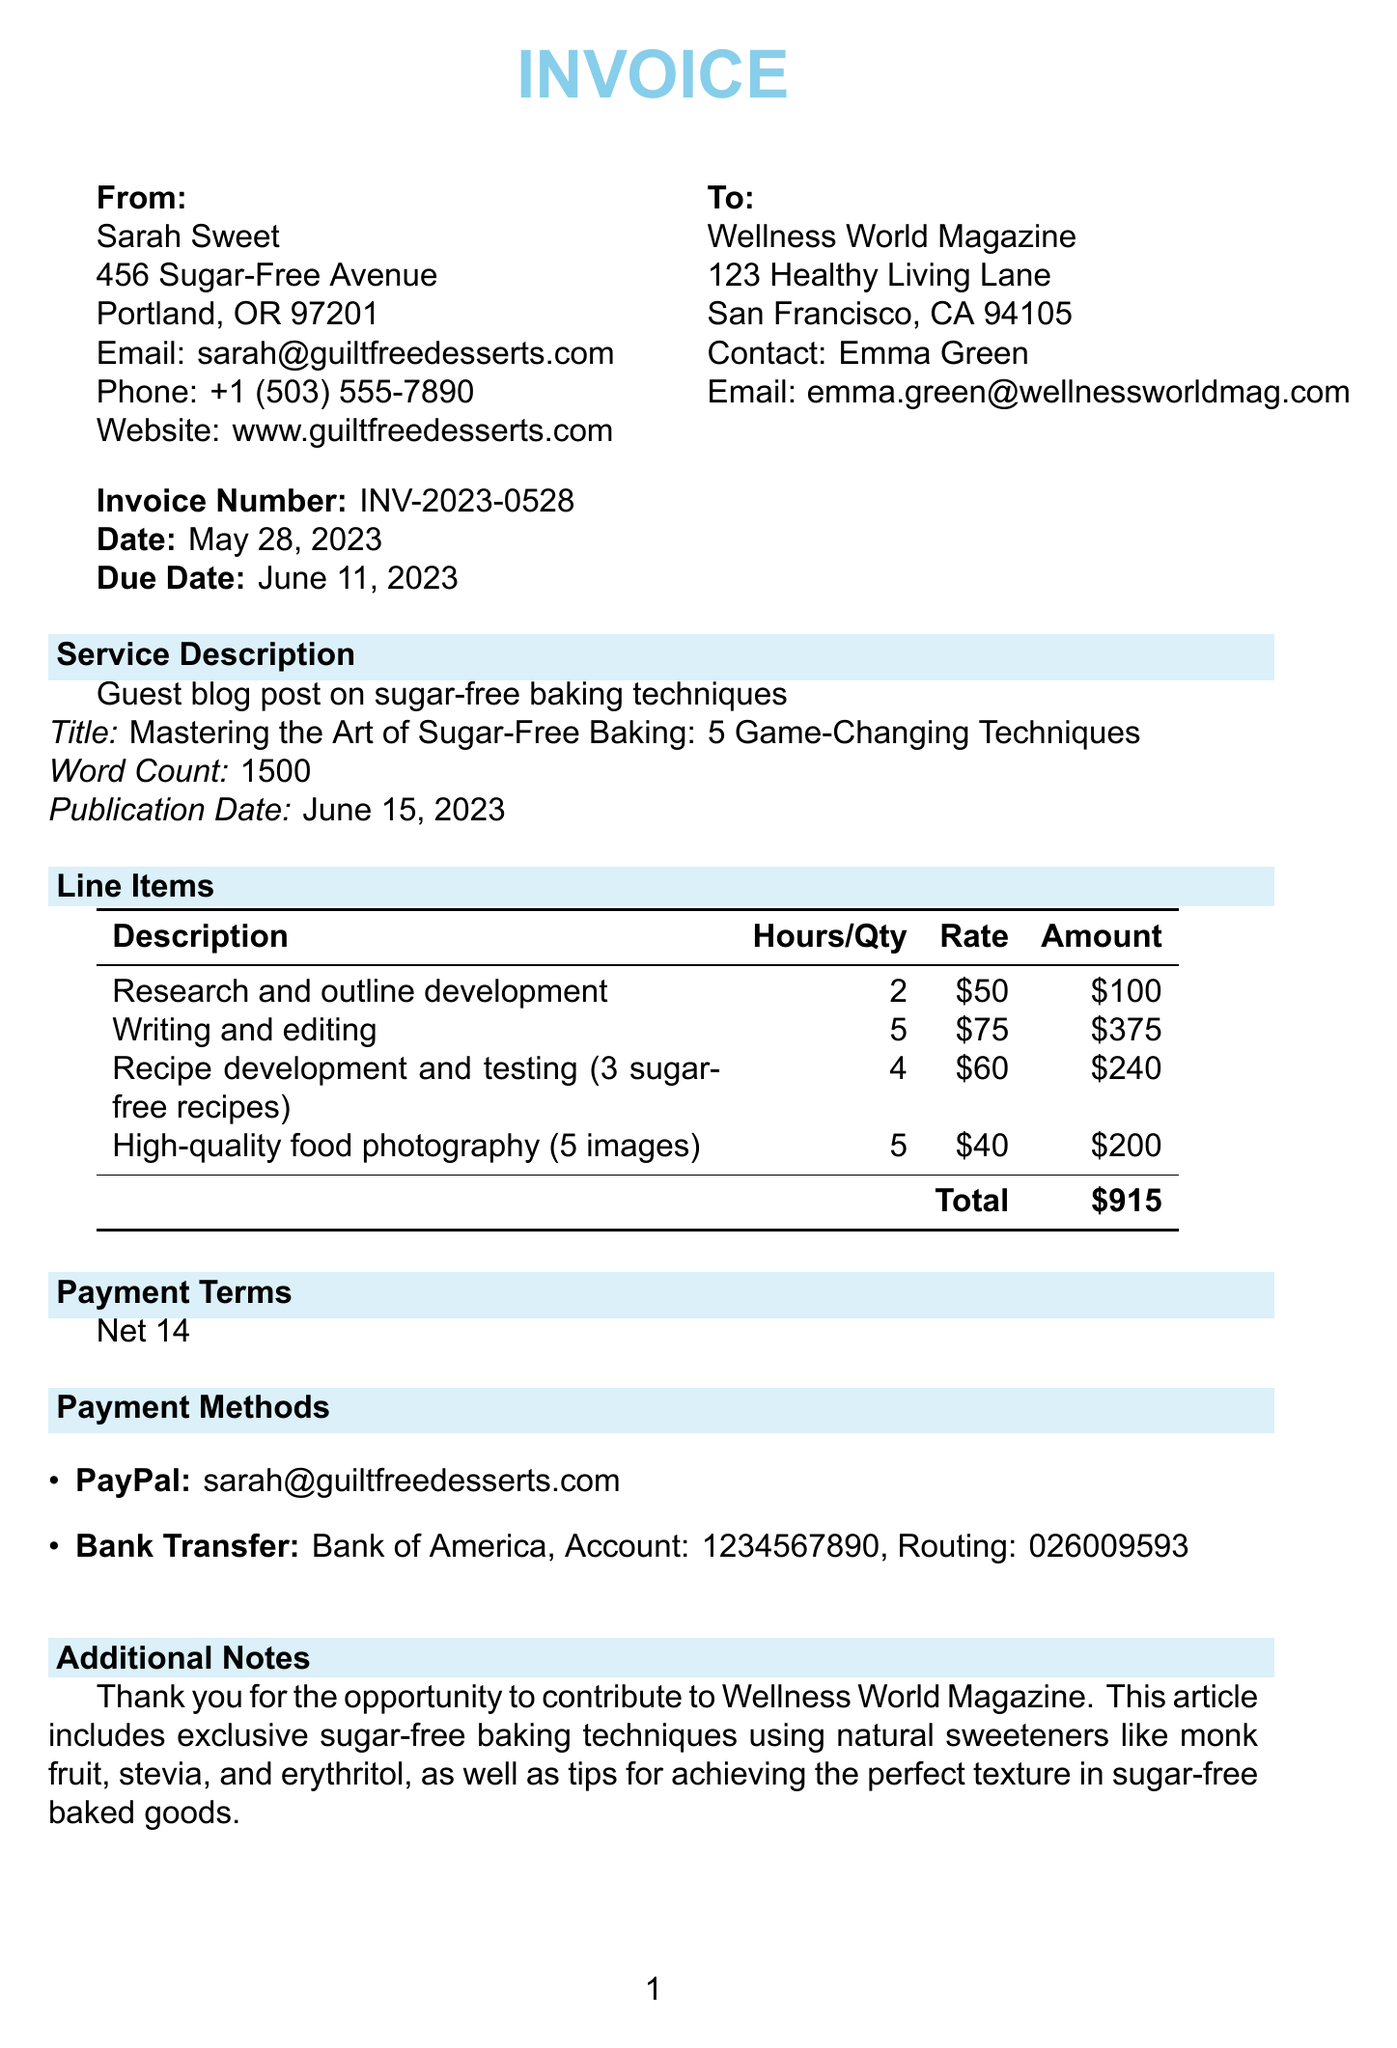What is the invoice number? The invoice number is a specific identifier for the transaction in the document.
Answer: INV-2023-0528 Who is the contact person for the client? The contact person is the individual representing the client organization in the document.
Answer: Emma Green What is the total amount due? The total amount due is the sum of all charges outlined in the invoice.
Answer: $915 When is the due date for the invoice? The due date indicates when the payment is expected, as listed in the document.
Answer: June 11, 2023 How many hours were spent on writing and editing? This number is specified in the line items and reflects the time allocated for that task.
Answer: 5 What is the primary service described in the invoice? The primary service details the work performed by the freelancer for the client.
Answer: Guest blog post on sugar-free baking techniques How many sugar-free recipes were developed? This quantity indicates the number of recipes created as part of the service rendered.
Answer: 3 What payment terms are specified in the invoice? These terms outline the conditions regarding when payment should be made.
Answer: Net 14 What methods of payment are accepted? This information reveals how the client can remit payment for the services rendered.
Answer: PayPal, Bank Transfer 